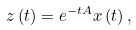<formula> <loc_0><loc_0><loc_500><loc_500>z \left ( t \right ) = e ^ { - t A } x \left ( t \right ) ,</formula> 